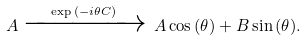<formula> <loc_0><loc_0><loc_500><loc_500>A \xrightarrow { \exp { ( - i \theta C ) } } \, A \cos { ( \theta ) } + B \sin { ( \theta ) } .</formula> 